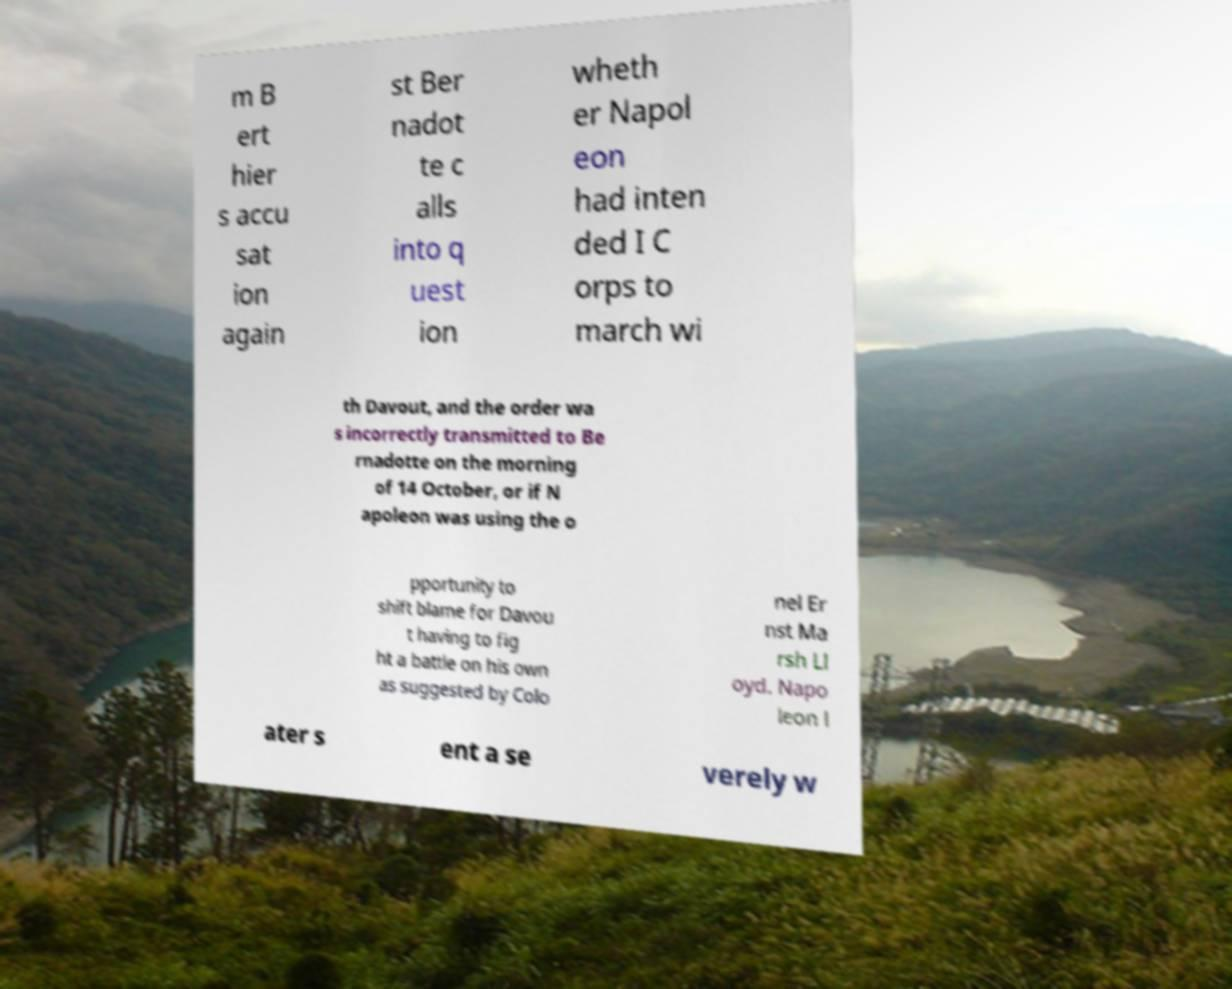What messages or text are displayed in this image? I need them in a readable, typed format. m B ert hier s accu sat ion again st Ber nadot te c alls into q uest ion wheth er Napol eon had inten ded I C orps to march wi th Davout, and the order wa s incorrectly transmitted to Be rnadotte on the morning of 14 October, or if N apoleon was using the o pportunity to shift blame for Davou t having to fig ht a battle on his own as suggested by Colo nel Er nst Ma rsh Ll oyd. Napo leon l ater s ent a se verely w 